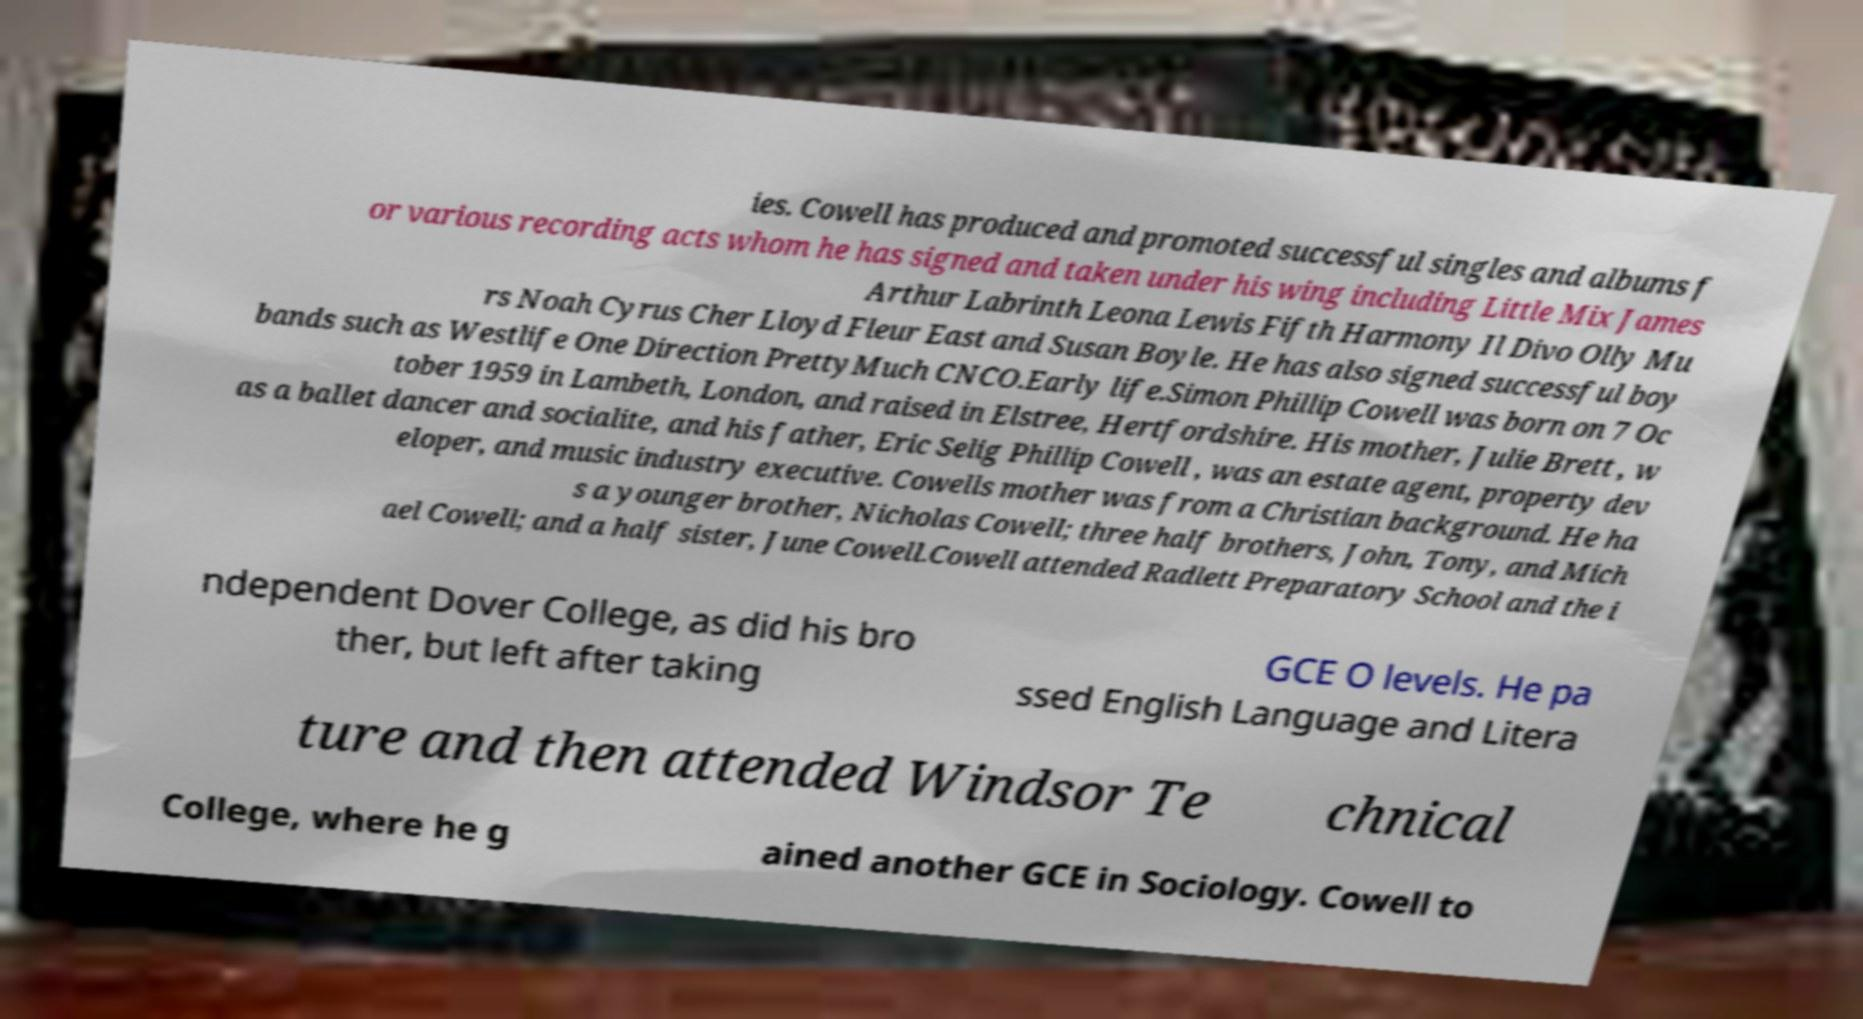For documentation purposes, I need the text within this image transcribed. Could you provide that? ies. Cowell has produced and promoted successful singles and albums f or various recording acts whom he has signed and taken under his wing including Little Mix James Arthur Labrinth Leona Lewis Fifth Harmony Il Divo Olly Mu rs Noah Cyrus Cher Lloyd Fleur East and Susan Boyle. He has also signed successful boy bands such as Westlife One Direction PrettyMuch CNCO.Early life.Simon Phillip Cowell was born on 7 Oc tober 1959 in Lambeth, London, and raised in Elstree, Hertfordshire. His mother, Julie Brett , w as a ballet dancer and socialite, and his father, Eric Selig Phillip Cowell , was an estate agent, property dev eloper, and music industry executive. Cowells mother was from a Christian background. He ha s a younger brother, Nicholas Cowell; three half brothers, John, Tony, and Mich ael Cowell; and a half sister, June Cowell.Cowell attended Radlett Preparatory School and the i ndependent Dover College, as did his bro ther, but left after taking GCE O levels. He pa ssed English Language and Litera ture and then attended Windsor Te chnical College, where he g ained another GCE in Sociology. Cowell to 